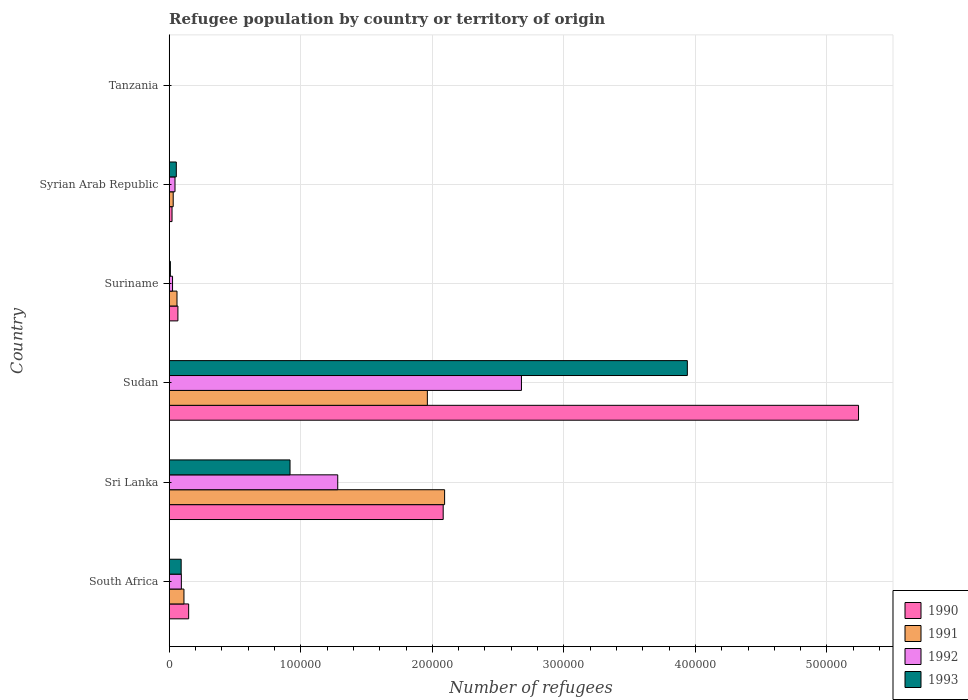How many different coloured bars are there?
Provide a succinct answer. 4. Are the number of bars per tick equal to the number of legend labels?
Ensure brevity in your answer.  Yes. What is the label of the 6th group of bars from the top?
Your answer should be compact. South Africa. In how many cases, is the number of bars for a given country not equal to the number of legend labels?
Your answer should be very brief. 0. What is the number of refugees in 1990 in Suriname?
Make the answer very short. 6620. Across all countries, what is the maximum number of refugees in 1991?
Your answer should be compact. 2.09e+05. Across all countries, what is the minimum number of refugees in 1992?
Give a very brief answer. 20. In which country was the number of refugees in 1990 maximum?
Keep it short and to the point. Sudan. In which country was the number of refugees in 1990 minimum?
Make the answer very short. Tanzania. What is the total number of refugees in 1992 in the graph?
Provide a short and direct response. 4.12e+05. What is the difference between the number of refugees in 1990 in Suriname and that in Syrian Arab Republic?
Ensure brevity in your answer.  4472. What is the difference between the number of refugees in 1992 in Syrian Arab Republic and the number of refugees in 1991 in Tanzania?
Make the answer very short. 4397. What is the average number of refugees in 1990 per country?
Provide a short and direct response. 1.26e+05. In how many countries, is the number of refugees in 1992 greater than 80000 ?
Keep it short and to the point. 2. What is the ratio of the number of refugees in 1993 in Sudan to that in Syrian Arab Republic?
Your answer should be compact. 72.89. Is the number of refugees in 1990 in South Africa less than that in Syrian Arab Republic?
Your answer should be very brief. No. Is the difference between the number of refugees in 1993 in Sri Lanka and Tanzania greater than the difference between the number of refugees in 1992 in Sri Lanka and Tanzania?
Give a very brief answer. No. What is the difference between the highest and the second highest number of refugees in 1992?
Make the answer very short. 1.40e+05. What is the difference between the highest and the lowest number of refugees in 1991?
Make the answer very short. 2.09e+05. Is the sum of the number of refugees in 1993 in Sudan and Tanzania greater than the maximum number of refugees in 1990 across all countries?
Provide a succinct answer. No. What does the 1st bar from the top in Tanzania represents?
Offer a very short reply. 1993. What does the 3rd bar from the bottom in Syrian Arab Republic represents?
Your answer should be very brief. 1992. Are all the bars in the graph horizontal?
Provide a succinct answer. Yes. Are the values on the major ticks of X-axis written in scientific E-notation?
Provide a short and direct response. No. Where does the legend appear in the graph?
Your response must be concise. Bottom right. How many legend labels are there?
Your answer should be very brief. 4. What is the title of the graph?
Make the answer very short. Refugee population by country or territory of origin. What is the label or title of the X-axis?
Your response must be concise. Number of refugees. What is the Number of refugees of 1990 in South Africa?
Give a very brief answer. 1.48e+04. What is the Number of refugees of 1991 in South Africa?
Provide a short and direct response. 1.12e+04. What is the Number of refugees in 1992 in South Africa?
Provide a succinct answer. 9241. What is the Number of refugees in 1993 in South Africa?
Offer a terse response. 9094. What is the Number of refugees in 1990 in Sri Lanka?
Your response must be concise. 2.08e+05. What is the Number of refugees in 1991 in Sri Lanka?
Offer a very short reply. 2.09e+05. What is the Number of refugees in 1992 in Sri Lanka?
Your response must be concise. 1.28e+05. What is the Number of refugees in 1993 in Sri Lanka?
Give a very brief answer. 9.18e+04. What is the Number of refugees in 1990 in Sudan?
Offer a terse response. 5.24e+05. What is the Number of refugees in 1991 in Sudan?
Your answer should be compact. 1.96e+05. What is the Number of refugees in 1992 in Sudan?
Your answer should be very brief. 2.68e+05. What is the Number of refugees in 1993 in Sudan?
Provide a succinct answer. 3.94e+05. What is the Number of refugees of 1990 in Suriname?
Offer a terse response. 6620. What is the Number of refugees of 1991 in Suriname?
Ensure brevity in your answer.  5921. What is the Number of refugees of 1992 in Suriname?
Ensure brevity in your answer.  2545. What is the Number of refugees in 1993 in Suriname?
Your response must be concise. 893. What is the Number of refugees of 1990 in Syrian Arab Republic?
Give a very brief answer. 2148. What is the Number of refugees of 1991 in Syrian Arab Republic?
Ensure brevity in your answer.  3037. What is the Number of refugees of 1992 in Syrian Arab Republic?
Make the answer very short. 4408. What is the Number of refugees of 1993 in Syrian Arab Republic?
Keep it short and to the point. 5404. What is the Number of refugees in 1992 in Tanzania?
Offer a terse response. 20. Across all countries, what is the maximum Number of refugees of 1990?
Provide a short and direct response. 5.24e+05. Across all countries, what is the maximum Number of refugees in 1991?
Your answer should be very brief. 2.09e+05. Across all countries, what is the maximum Number of refugees in 1992?
Offer a very short reply. 2.68e+05. Across all countries, what is the maximum Number of refugees in 1993?
Your answer should be very brief. 3.94e+05. Across all countries, what is the minimum Number of refugees of 1991?
Your response must be concise. 11. Across all countries, what is the minimum Number of refugees of 1992?
Provide a succinct answer. 20. Across all countries, what is the minimum Number of refugees of 1993?
Ensure brevity in your answer.  32. What is the total Number of refugees in 1990 in the graph?
Your answer should be very brief. 7.56e+05. What is the total Number of refugees in 1991 in the graph?
Ensure brevity in your answer.  4.26e+05. What is the total Number of refugees of 1992 in the graph?
Your response must be concise. 4.12e+05. What is the total Number of refugees in 1993 in the graph?
Your response must be concise. 5.01e+05. What is the difference between the Number of refugees of 1990 in South Africa and that in Sri Lanka?
Ensure brevity in your answer.  -1.93e+05. What is the difference between the Number of refugees in 1991 in South Africa and that in Sri Lanka?
Your answer should be compact. -1.98e+05. What is the difference between the Number of refugees of 1992 in South Africa and that in Sri Lanka?
Your response must be concise. -1.19e+05. What is the difference between the Number of refugees of 1993 in South Africa and that in Sri Lanka?
Provide a short and direct response. -8.28e+04. What is the difference between the Number of refugees in 1990 in South Africa and that in Sudan?
Your answer should be very brief. -5.09e+05. What is the difference between the Number of refugees in 1991 in South Africa and that in Sudan?
Provide a short and direct response. -1.85e+05. What is the difference between the Number of refugees in 1992 in South Africa and that in Sudan?
Ensure brevity in your answer.  -2.59e+05. What is the difference between the Number of refugees in 1993 in South Africa and that in Sudan?
Offer a very short reply. -3.85e+05. What is the difference between the Number of refugees in 1990 in South Africa and that in Suriname?
Your response must be concise. 8163. What is the difference between the Number of refugees of 1991 in South Africa and that in Suriname?
Provide a short and direct response. 5285. What is the difference between the Number of refugees in 1992 in South Africa and that in Suriname?
Offer a terse response. 6696. What is the difference between the Number of refugees of 1993 in South Africa and that in Suriname?
Provide a succinct answer. 8201. What is the difference between the Number of refugees of 1990 in South Africa and that in Syrian Arab Republic?
Provide a short and direct response. 1.26e+04. What is the difference between the Number of refugees of 1991 in South Africa and that in Syrian Arab Republic?
Make the answer very short. 8169. What is the difference between the Number of refugees in 1992 in South Africa and that in Syrian Arab Republic?
Your answer should be compact. 4833. What is the difference between the Number of refugees in 1993 in South Africa and that in Syrian Arab Republic?
Your answer should be very brief. 3690. What is the difference between the Number of refugees of 1990 in South Africa and that in Tanzania?
Your response must be concise. 1.48e+04. What is the difference between the Number of refugees in 1991 in South Africa and that in Tanzania?
Provide a short and direct response. 1.12e+04. What is the difference between the Number of refugees in 1992 in South Africa and that in Tanzania?
Ensure brevity in your answer.  9221. What is the difference between the Number of refugees of 1993 in South Africa and that in Tanzania?
Provide a succinct answer. 9062. What is the difference between the Number of refugees in 1990 in Sri Lanka and that in Sudan?
Keep it short and to the point. -3.16e+05. What is the difference between the Number of refugees of 1991 in Sri Lanka and that in Sudan?
Ensure brevity in your answer.  1.31e+04. What is the difference between the Number of refugees in 1992 in Sri Lanka and that in Sudan?
Ensure brevity in your answer.  -1.40e+05. What is the difference between the Number of refugees in 1993 in Sri Lanka and that in Sudan?
Your answer should be compact. -3.02e+05. What is the difference between the Number of refugees in 1990 in Sri Lanka and that in Suriname?
Your answer should be very brief. 2.02e+05. What is the difference between the Number of refugees in 1991 in Sri Lanka and that in Suriname?
Give a very brief answer. 2.03e+05. What is the difference between the Number of refugees of 1992 in Sri Lanka and that in Suriname?
Ensure brevity in your answer.  1.26e+05. What is the difference between the Number of refugees of 1993 in Sri Lanka and that in Suriname?
Ensure brevity in your answer.  9.10e+04. What is the difference between the Number of refugees of 1990 in Sri Lanka and that in Syrian Arab Republic?
Offer a terse response. 2.06e+05. What is the difference between the Number of refugees of 1991 in Sri Lanka and that in Syrian Arab Republic?
Offer a very short reply. 2.06e+05. What is the difference between the Number of refugees of 1992 in Sri Lanka and that in Syrian Arab Republic?
Ensure brevity in your answer.  1.24e+05. What is the difference between the Number of refugees of 1993 in Sri Lanka and that in Syrian Arab Republic?
Provide a succinct answer. 8.64e+04. What is the difference between the Number of refugees in 1990 in Sri Lanka and that in Tanzania?
Provide a short and direct response. 2.08e+05. What is the difference between the Number of refugees in 1991 in Sri Lanka and that in Tanzania?
Your response must be concise. 2.09e+05. What is the difference between the Number of refugees in 1992 in Sri Lanka and that in Tanzania?
Give a very brief answer. 1.28e+05. What is the difference between the Number of refugees in 1993 in Sri Lanka and that in Tanzania?
Ensure brevity in your answer.  9.18e+04. What is the difference between the Number of refugees of 1990 in Sudan and that in Suriname?
Give a very brief answer. 5.17e+05. What is the difference between the Number of refugees in 1991 in Sudan and that in Suriname?
Your response must be concise. 1.90e+05. What is the difference between the Number of refugees of 1992 in Sudan and that in Suriname?
Offer a terse response. 2.65e+05. What is the difference between the Number of refugees of 1993 in Sudan and that in Suriname?
Give a very brief answer. 3.93e+05. What is the difference between the Number of refugees of 1990 in Sudan and that in Syrian Arab Republic?
Ensure brevity in your answer.  5.22e+05. What is the difference between the Number of refugees of 1991 in Sudan and that in Syrian Arab Republic?
Ensure brevity in your answer.  1.93e+05. What is the difference between the Number of refugees of 1992 in Sudan and that in Syrian Arab Republic?
Make the answer very short. 2.63e+05. What is the difference between the Number of refugees in 1993 in Sudan and that in Syrian Arab Republic?
Your answer should be very brief. 3.88e+05. What is the difference between the Number of refugees of 1990 in Sudan and that in Tanzania?
Ensure brevity in your answer.  5.24e+05. What is the difference between the Number of refugees in 1991 in Sudan and that in Tanzania?
Make the answer very short. 1.96e+05. What is the difference between the Number of refugees of 1992 in Sudan and that in Tanzania?
Offer a terse response. 2.68e+05. What is the difference between the Number of refugees of 1993 in Sudan and that in Tanzania?
Offer a very short reply. 3.94e+05. What is the difference between the Number of refugees of 1990 in Suriname and that in Syrian Arab Republic?
Offer a terse response. 4472. What is the difference between the Number of refugees in 1991 in Suriname and that in Syrian Arab Republic?
Ensure brevity in your answer.  2884. What is the difference between the Number of refugees in 1992 in Suriname and that in Syrian Arab Republic?
Provide a succinct answer. -1863. What is the difference between the Number of refugees in 1993 in Suriname and that in Syrian Arab Republic?
Ensure brevity in your answer.  -4511. What is the difference between the Number of refugees of 1990 in Suriname and that in Tanzania?
Your response must be concise. 6612. What is the difference between the Number of refugees of 1991 in Suriname and that in Tanzania?
Your answer should be compact. 5910. What is the difference between the Number of refugees in 1992 in Suriname and that in Tanzania?
Your response must be concise. 2525. What is the difference between the Number of refugees in 1993 in Suriname and that in Tanzania?
Make the answer very short. 861. What is the difference between the Number of refugees in 1990 in Syrian Arab Republic and that in Tanzania?
Give a very brief answer. 2140. What is the difference between the Number of refugees in 1991 in Syrian Arab Republic and that in Tanzania?
Your answer should be compact. 3026. What is the difference between the Number of refugees in 1992 in Syrian Arab Republic and that in Tanzania?
Ensure brevity in your answer.  4388. What is the difference between the Number of refugees of 1993 in Syrian Arab Republic and that in Tanzania?
Offer a very short reply. 5372. What is the difference between the Number of refugees of 1990 in South Africa and the Number of refugees of 1991 in Sri Lanka?
Offer a terse response. -1.95e+05. What is the difference between the Number of refugees in 1990 in South Africa and the Number of refugees in 1992 in Sri Lanka?
Your response must be concise. -1.13e+05. What is the difference between the Number of refugees of 1990 in South Africa and the Number of refugees of 1993 in Sri Lanka?
Keep it short and to the point. -7.71e+04. What is the difference between the Number of refugees in 1991 in South Africa and the Number of refugees in 1992 in Sri Lanka?
Offer a terse response. -1.17e+05. What is the difference between the Number of refugees of 1991 in South Africa and the Number of refugees of 1993 in Sri Lanka?
Provide a succinct answer. -8.06e+04. What is the difference between the Number of refugees of 1992 in South Africa and the Number of refugees of 1993 in Sri Lanka?
Your response must be concise. -8.26e+04. What is the difference between the Number of refugees in 1990 in South Africa and the Number of refugees in 1991 in Sudan?
Keep it short and to the point. -1.81e+05. What is the difference between the Number of refugees in 1990 in South Africa and the Number of refugees in 1992 in Sudan?
Your answer should be compact. -2.53e+05. What is the difference between the Number of refugees in 1990 in South Africa and the Number of refugees in 1993 in Sudan?
Give a very brief answer. -3.79e+05. What is the difference between the Number of refugees of 1991 in South Africa and the Number of refugees of 1992 in Sudan?
Provide a short and direct response. -2.57e+05. What is the difference between the Number of refugees in 1991 in South Africa and the Number of refugees in 1993 in Sudan?
Provide a succinct answer. -3.83e+05. What is the difference between the Number of refugees in 1992 in South Africa and the Number of refugees in 1993 in Sudan?
Give a very brief answer. -3.85e+05. What is the difference between the Number of refugees in 1990 in South Africa and the Number of refugees in 1991 in Suriname?
Give a very brief answer. 8862. What is the difference between the Number of refugees in 1990 in South Africa and the Number of refugees in 1992 in Suriname?
Your answer should be very brief. 1.22e+04. What is the difference between the Number of refugees in 1990 in South Africa and the Number of refugees in 1993 in Suriname?
Offer a very short reply. 1.39e+04. What is the difference between the Number of refugees in 1991 in South Africa and the Number of refugees in 1992 in Suriname?
Your answer should be compact. 8661. What is the difference between the Number of refugees of 1991 in South Africa and the Number of refugees of 1993 in Suriname?
Your response must be concise. 1.03e+04. What is the difference between the Number of refugees in 1992 in South Africa and the Number of refugees in 1993 in Suriname?
Your response must be concise. 8348. What is the difference between the Number of refugees of 1990 in South Africa and the Number of refugees of 1991 in Syrian Arab Republic?
Your answer should be very brief. 1.17e+04. What is the difference between the Number of refugees in 1990 in South Africa and the Number of refugees in 1992 in Syrian Arab Republic?
Offer a terse response. 1.04e+04. What is the difference between the Number of refugees of 1990 in South Africa and the Number of refugees of 1993 in Syrian Arab Republic?
Your response must be concise. 9379. What is the difference between the Number of refugees of 1991 in South Africa and the Number of refugees of 1992 in Syrian Arab Republic?
Offer a terse response. 6798. What is the difference between the Number of refugees in 1991 in South Africa and the Number of refugees in 1993 in Syrian Arab Republic?
Keep it short and to the point. 5802. What is the difference between the Number of refugees in 1992 in South Africa and the Number of refugees in 1993 in Syrian Arab Republic?
Provide a succinct answer. 3837. What is the difference between the Number of refugees in 1990 in South Africa and the Number of refugees in 1991 in Tanzania?
Give a very brief answer. 1.48e+04. What is the difference between the Number of refugees of 1990 in South Africa and the Number of refugees of 1992 in Tanzania?
Provide a short and direct response. 1.48e+04. What is the difference between the Number of refugees of 1990 in South Africa and the Number of refugees of 1993 in Tanzania?
Keep it short and to the point. 1.48e+04. What is the difference between the Number of refugees in 1991 in South Africa and the Number of refugees in 1992 in Tanzania?
Your answer should be very brief. 1.12e+04. What is the difference between the Number of refugees in 1991 in South Africa and the Number of refugees in 1993 in Tanzania?
Make the answer very short. 1.12e+04. What is the difference between the Number of refugees of 1992 in South Africa and the Number of refugees of 1993 in Tanzania?
Provide a short and direct response. 9209. What is the difference between the Number of refugees of 1990 in Sri Lanka and the Number of refugees of 1991 in Sudan?
Keep it short and to the point. 1.20e+04. What is the difference between the Number of refugees of 1990 in Sri Lanka and the Number of refugees of 1992 in Sudan?
Provide a succinct answer. -5.95e+04. What is the difference between the Number of refugees of 1990 in Sri Lanka and the Number of refugees of 1993 in Sudan?
Ensure brevity in your answer.  -1.86e+05. What is the difference between the Number of refugees in 1991 in Sri Lanka and the Number of refugees in 1992 in Sudan?
Provide a succinct answer. -5.84e+04. What is the difference between the Number of refugees in 1991 in Sri Lanka and the Number of refugees in 1993 in Sudan?
Provide a short and direct response. -1.85e+05. What is the difference between the Number of refugees in 1992 in Sri Lanka and the Number of refugees in 1993 in Sudan?
Offer a very short reply. -2.66e+05. What is the difference between the Number of refugees of 1990 in Sri Lanka and the Number of refugees of 1991 in Suriname?
Make the answer very short. 2.02e+05. What is the difference between the Number of refugees in 1990 in Sri Lanka and the Number of refugees in 1992 in Suriname?
Offer a terse response. 2.06e+05. What is the difference between the Number of refugees in 1990 in Sri Lanka and the Number of refugees in 1993 in Suriname?
Keep it short and to the point. 2.07e+05. What is the difference between the Number of refugees in 1991 in Sri Lanka and the Number of refugees in 1992 in Suriname?
Your answer should be very brief. 2.07e+05. What is the difference between the Number of refugees of 1991 in Sri Lanka and the Number of refugees of 1993 in Suriname?
Provide a short and direct response. 2.08e+05. What is the difference between the Number of refugees in 1992 in Sri Lanka and the Number of refugees in 1993 in Suriname?
Your answer should be compact. 1.27e+05. What is the difference between the Number of refugees in 1990 in Sri Lanka and the Number of refugees in 1991 in Syrian Arab Republic?
Give a very brief answer. 2.05e+05. What is the difference between the Number of refugees in 1990 in Sri Lanka and the Number of refugees in 1992 in Syrian Arab Republic?
Keep it short and to the point. 2.04e+05. What is the difference between the Number of refugees in 1990 in Sri Lanka and the Number of refugees in 1993 in Syrian Arab Republic?
Your response must be concise. 2.03e+05. What is the difference between the Number of refugees of 1991 in Sri Lanka and the Number of refugees of 1992 in Syrian Arab Republic?
Offer a very short reply. 2.05e+05. What is the difference between the Number of refugees of 1991 in Sri Lanka and the Number of refugees of 1993 in Syrian Arab Republic?
Keep it short and to the point. 2.04e+05. What is the difference between the Number of refugees in 1992 in Sri Lanka and the Number of refugees in 1993 in Syrian Arab Republic?
Provide a succinct answer. 1.23e+05. What is the difference between the Number of refugees in 1990 in Sri Lanka and the Number of refugees in 1991 in Tanzania?
Keep it short and to the point. 2.08e+05. What is the difference between the Number of refugees of 1990 in Sri Lanka and the Number of refugees of 1992 in Tanzania?
Offer a terse response. 2.08e+05. What is the difference between the Number of refugees of 1990 in Sri Lanka and the Number of refugees of 1993 in Tanzania?
Keep it short and to the point. 2.08e+05. What is the difference between the Number of refugees of 1991 in Sri Lanka and the Number of refugees of 1992 in Tanzania?
Make the answer very short. 2.09e+05. What is the difference between the Number of refugees of 1991 in Sri Lanka and the Number of refugees of 1993 in Tanzania?
Your answer should be compact. 2.09e+05. What is the difference between the Number of refugees of 1992 in Sri Lanka and the Number of refugees of 1993 in Tanzania?
Make the answer very short. 1.28e+05. What is the difference between the Number of refugees in 1990 in Sudan and the Number of refugees in 1991 in Suriname?
Keep it short and to the point. 5.18e+05. What is the difference between the Number of refugees of 1990 in Sudan and the Number of refugees of 1992 in Suriname?
Give a very brief answer. 5.21e+05. What is the difference between the Number of refugees of 1990 in Sudan and the Number of refugees of 1993 in Suriname?
Make the answer very short. 5.23e+05. What is the difference between the Number of refugees of 1991 in Sudan and the Number of refugees of 1992 in Suriname?
Give a very brief answer. 1.94e+05. What is the difference between the Number of refugees of 1991 in Sudan and the Number of refugees of 1993 in Suriname?
Offer a terse response. 1.95e+05. What is the difference between the Number of refugees of 1992 in Sudan and the Number of refugees of 1993 in Suriname?
Provide a succinct answer. 2.67e+05. What is the difference between the Number of refugees of 1990 in Sudan and the Number of refugees of 1991 in Syrian Arab Republic?
Provide a succinct answer. 5.21e+05. What is the difference between the Number of refugees of 1990 in Sudan and the Number of refugees of 1992 in Syrian Arab Republic?
Give a very brief answer. 5.20e+05. What is the difference between the Number of refugees in 1990 in Sudan and the Number of refugees in 1993 in Syrian Arab Republic?
Your response must be concise. 5.19e+05. What is the difference between the Number of refugees in 1991 in Sudan and the Number of refugees in 1992 in Syrian Arab Republic?
Offer a very short reply. 1.92e+05. What is the difference between the Number of refugees of 1991 in Sudan and the Number of refugees of 1993 in Syrian Arab Republic?
Your response must be concise. 1.91e+05. What is the difference between the Number of refugees in 1992 in Sudan and the Number of refugees in 1993 in Syrian Arab Republic?
Give a very brief answer. 2.62e+05. What is the difference between the Number of refugees in 1990 in Sudan and the Number of refugees in 1991 in Tanzania?
Offer a terse response. 5.24e+05. What is the difference between the Number of refugees of 1990 in Sudan and the Number of refugees of 1992 in Tanzania?
Offer a very short reply. 5.24e+05. What is the difference between the Number of refugees of 1990 in Sudan and the Number of refugees of 1993 in Tanzania?
Offer a terse response. 5.24e+05. What is the difference between the Number of refugees in 1991 in Sudan and the Number of refugees in 1992 in Tanzania?
Provide a short and direct response. 1.96e+05. What is the difference between the Number of refugees of 1991 in Sudan and the Number of refugees of 1993 in Tanzania?
Provide a short and direct response. 1.96e+05. What is the difference between the Number of refugees of 1992 in Sudan and the Number of refugees of 1993 in Tanzania?
Ensure brevity in your answer.  2.68e+05. What is the difference between the Number of refugees of 1990 in Suriname and the Number of refugees of 1991 in Syrian Arab Republic?
Keep it short and to the point. 3583. What is the difference between the Number of refugees in 1990 in Suriname and the Number of refugees in 1992 in Syrian Arab Republic?
Make the answer very short. 2212. What is the difference between the Number of refugees in 1990 in Suriname and the Number of refugees in 1993 in Syrian Arab Republic?
Your answer should be compact. 1216. What is the difference between the Number of refugees of 1991 in Suriname and the Number of refugees of 1992 in Syrian Arab Republic?
Offer a very short reply. 1513. What is the difference between the Number of refugees of 1991 in Suriname and the Number of refugees of 1993 in Syrian Arab Republic?
Your response must be concise. 517. What is the difference between the Number of refugees of 1992 in Suriname and the Number of refugees of 1993 in Syrian Arab Republic?
Your answer should be compact. -2859. What is the difference between the Number of refugees in 1990 in Suriname and the Number of refugees in 1991 in Tanzania?
Ensure brevity in your answer.  6609. What is the difference between the Number of refugees in 1990 in Suriname and the Number of refugees in 1992 in Tanzania?
Keep it short and to the point. 6600. What is the difference between the Number of refugees in 1990 in Suriname and the Number of refugees in 1993 in Tanzania?
Offer a very short reply. 6588. What is the difference between the Number of refugees of 1991 in Suriname and the Number of refugees of 1992 in Tanzania?
Offer a very short reply. 5901. What is the difference between the Number of refugees of 1991 in Suriname and the Number of refugees of 1993 in Tanzania?
Offer a very short reply. 5889. What is the difference between the Number of refugees of 1992 in Suriname and the Number of refugees of 1993 in Tanzania?
Your response must be concise. 2513. What is the difference between the Number of refugees of 1990 in Syrian Arab Republic and the Number of refugees of 1991 in Tanzania?
Offer a very short reply. 2137. What is the difference between the Number of refugees of 1990 in Syrian Arab Republic and the Number of refugees of 1992 in Tanzania?
Give a very brief answer. 2128. What is the difference between the Number of refugees in 1990 in Syrian Arab Republic and the Number of refugees in 1993 in Tanzania?
Give a very brief answer. 2116. What is the difference between the Number of refugees in 1991 in Syrian Arab Republic and the Number of refugees in 1992 in Tanzania?
Give a very brief answer. 3017. What is the difference between the Number of refugees of 1991 in Syrian Arab Republic and the Number of refugees of 1993 in Tanzania?
Make the answer very short. 3005. What is the difference between the Number of refugees in 1992 in Syrian Arab Republic and the Number of refugees in 1993 in Tanzania?
Make the answer very short. 4376. What is the average Number of refugees in 1990 per country?
Offer a very short reply. 1.26e+05. What is the average Number of refugees of 1991 per country?
Your answer should be compact. 7.10e+04. What is the average Number of refugees of 1992 per country?
Ensure brevity in your answer.  6.87e+04. What is the average Number of refugees in 1993 per country?
Your answer should be compact. 8.35e+04. What is the difference between the Number of refugees of 1990 and Number of refugees of 1991 in South Africa?
Your answer should be very brief. 3577. What is the difference between the Number of refugees of 1990 and Number of refugees of 1992 in South Africa?
Your response must be concise. 5542. What is the difference between the Number of refugees in 1990 and Number of refugees in 1993 in South Africa?
Keep it short and to the point. 5689. What is the difference between the Number of refugees of 1991 and Number of refugees of 1992 in South Africa?
Your answer should be very brief. 1965. What is the difference between the Number of refugees in 1991 and Number of refugees in 1993 in South Africa?
Offer a very short reply. 2112. What is the difference between the Number of refugees in 1992 and Number of refugees in 1993 in South Africa?
Make the answer very short. 147. What is the difference between the Number of refugees of 1990 and Number of refugees of 1991 in Sri Lanka?
Make the answer very short. -1078. What is the difference between the Number of refugees in 1990 and Number of refugees in 1992 in Sri Lanka?
Your response must be concise. 8.02e+04. What is the difference between the Number of refugees in 1990 and Number of refugees in 1993 in Sri Lanka?
Give a very brief answer. 1.16e+05. What is the difference between the Number of refugees in 1991 and Number of refugees in 1992 in Sri Lanka?
Your response must be concise. 8.12e+04. What is the difference between the Number of refugees of 1991 and Number of refugees of 1993 in Sri Lanka?
Your answer should be compact. 1.18e+05. What is the difference between the Number of refugees in 1992 and Number of refugees in 1993 in Sri Lanka?
Make the answer very short. 3.63e+04. What is the difference between the Number of refugees of 1990 and Number of refugees of 1991 in Sudan?
Offer a very short reply. 3.28e+05. What is the difference between the Number of refugees of 1990 and Number of refugees of 1992 in Sudan?
Provide a succinct answer. 2.56e+05. What is the difference between the Number of refugees of 1990 and Number of refugees of 1993 in Sudan?
Provide a short and direct response. 1.30e+05. What is the difference between the Number of refugees of 1991 and Number of refugees of 1992 in Sudan?
Provide a short and direct response. -7.15e+04. What is the difference between the Number of refugees in 1991 and Number of refugees in 1993 in Sudan?
Your answer should be very brief. -1.98e+05. What is the difference between the Number of refugees of 1992 and Number of refugees of 1993 in Sudan?
Your response must be concise. -1.26e+05. What is the difference between the Number of refugees of 1990 and Number of refugees of 1991 in Suriname?
Your answer should be very brief. 699. What is the difference between the Number of refugees of 1990 and Number of refugees of 1992 in Suriname?
Ensure brevity in your answer.  4075. What is the difference between the Number of refugees of 1990 and Number of refugees of 1993 in Suriname?
Make the answer very short. 5727. What is the difference between the Number of refugees in 1991 and Number of refugees in 1992 in Suriname?
Your answer should be compact. 3376. What is the difference between the Number of refugees in 1991 and Number of refugees in 1993 in Suriname?
Give a very brief answer. 5028. What is the difference between the Number of refugees in 1992 and Number of refugees in 1993 in Suriname?
Ensure brevity in your answer.  1652. What is the difference between the Number of refugees in 1990 and Number of refugees in 1991 in Syrian Arab Republic?
Your answer should be very brief. -889. What is the difference between the Number of refugees of 1990 and Number of refugees of 1992 in Syrian Arab Republic?
Your answer should be compact. -2260. What is the difference between the Number of refugees in 1990 and Number of refugees in 1993 in Syrian Arab Republic?
Ensure brevity in your answer.  -3256. What is the difference between the Number of refugees of 1991 and Number of refugees of 1992 in Syrian Arab Republic?
Provide a succinct answer. -1371. What is the difference between the Number of refugees in 1991 and Number of refugees in 1993 in Syrian Arab Republic?
Your answer should be very brief. -2367. What is the difference between the Number of refugees in 1992 and Number of refugees in 1993 in Syrian Arab Republic?
Your answer should be compact. -996. What is the difference between the Number of refugees of 1990 and Number of refugees of 1992 in Tanzania?
Provide a succinct answer. -12. What is the difference between the Number of refugees of 1990 and Number of refugees of 1993 in Tanzania?
Keep it short and to the point. -24. What is the difference between the Number of refugees of 1992 and Number of refugees of 1993 in Tanzania?
Provide a succinct answer. -12. What is the ratio of the Number of refugees in 1990 in South Africa to that in Sri Lanka?
Make the answer very short. 0.07. What is the ratio of the Number of refugees of 1991 in South Africa to that in Sri Lanka?
Your answer should be very brief. 0.05. What is the ratio of the Number of refugees in 1992 in South Africa to that in Sri Lanka?
Your answer should be very brief. 0.07. What is the ratio of the Number of refugees of 1993 in South Africa to that in Sri Lanka?
Provide a succinct answer. 0.1. What is the ratio of the Number of refugees in 1990 in South Africa to that in Sudan?
Provide a succinct answer. 0.03. What is the ratio of the Number of refugees of 1991 in South Africa to that in Sudan?
Make the answer very short. 0.06. What is the ratio of the Number of refugees of 1992 in South Africa to that in Sudan?
Your response must be concise. 0.03. What is the ratio of the Number of refugees of 1993 in South Africa to that in Sudan?
Keep it short and to the point. 0.02. What is the ratio of the Number of refugees in 1990 in South Africa to that in Suriname?
Provide a short and direct response. 2.23. What is the ratio of the Number of refugees in 1991 in South Africa to that in Suriname?
Ensure brevity in your answer.  1.89. What is the ratio of the Number of refugees of 1992 in South Africa to that in Suriname?
Provide a succinct answer. 3.63. What is the ratio of the Number of refugees in 1993 in South Africa to that in Suriname?
Make the answer very short. 10.18. What is the ratio of the Number of refugees of 1990 in South Africa to that in Syrian Arab Republic?
Your answer should be very brief. 6.88. What is the ratio of the Number of refugees of 1991 in South Africa to that in Syrian Arab Republic?
Your answer should be very brief. 3.69. What is the ratio of the Number of refugees in 1992 in South Africa to that in Syrian Arab Republic?
Your response must be concise. 2.1. What is the ratio of the Number of refugees in 1993 in South Africa to that in Syrian Arab Republic?
Your response must be concise. 1.68. What is the ratio of the Number of refugees of 1990 in South Africa to that in Tanzania?
Ensure brevity in your answer.  1847.88. What is the ratio of the Number of refugees of 1991 in South Africa to that in Tanzania?
Your response must be concise. 1018.73. What is the ratio of the Number of refugees of 1992 in South Africa to that in Tanzania?
Provide a succinct answer. 462.05. What is the ratio of the Number of refugees of 1993 in South Africa to that in Tanzania?
Your answer should be very brief. 284.19. What is the ratio of the Number of refugees of 1990 in Sri Lanka to that in Sudan?
Your answer should be very brief. 0.4. What is the ratio of the Number of refugees of 1991 in Sri Lanka to that in Sudan?
Offer a very short reply. 1.07. What is the ratio of the Number of refugees in 1992 in Sri Lanka to that in Sudan?
Your response must be concise. 0.48. What is the ratio of the Number of refugees in 1993 in Sri Lanka to that in Sudan?
Your response must be concise. 0.23. What is the ratio of the Number of refugees of 1990 in Sri Lanka to that in Suriname?
Keep it short and to the point. 31.46. What is the ratio of the Number of refugees of 1991 in Sri Lanka to that in Suriname?
Give a very brief answer. 35.36. What is the ratio of the Number of refugees in 1992 in Sri Lanka to that in Suriname?
Offer a very short reply. 50.34. What is the ratio of the Number of refugees in 1993 in Sri Lanka to that in Suriname?
Your response must be concise. 102.85. What is the ratio of the Number of refugees of 1990 in Sri Lanka to that in Syrian Arab Republic?
Offer a very short reply. 96.96. What is the ratio of the Number of refugees of 1991 in Sri Lanka to that in Syrian Arab Republic?
Offer a very short reply. 68.93. What is the ratio of the Number of refugees in 1992 in Sri Lanka to that in Syrian Arab Republic?
Make the answer very short. 29.06. What is the ratio of the Number of refugees in 1993 in Sri Lanka to that in Syrian Arab Republic?
Make the answer very short. 17. What is the ratio of the Number of refugees of 1990 in Sri Lanka to that in Tanzania?
Provide a succinct answer. 2.60e+04. What is the ratio of the Number of refugees in 1991 in Sri Lanka to that in Tanzania?
Make the answer very short. 1.90e+04. What is the ratio of the Number of refugees of 1992 in Sri Lanka to that in Tanzania?
Your answer should be very brief. 6405.75. What is the ratio of the Number of refugees in 1993 in Sri Lanka to that in Tanzania?
Keep it short and to the point. 2870.16. What is the ratio of the Number of refugees of 1990 in Sudan to that in Suriname?
Make the answer very short. 79.15. What is the ratio of the Number of refugees in 1991 in Sudan to that in Suriname?
Provide a succinct answer. 33.14. What is the ratio of the Number of refugees of 1992 in Sudan to that in Suriname?
Keep it short and to the point. 105.21. What is the ratio of the Number of refugees of 1993 in Sudan to that in Suriname?
Your response must be concise. 441.06. What is the ratio of the Number of refugees in 1990 in Sudan to that in Syrian Arab Republic?
Offer a terse response. 243.95. What is the ratio of the Number of refugees of 1991 in Sudan to that in Syrian Arab Republic?
Your answer should be very brief. 64.62. What is the ratio of the Number of refugees in 1992 in Sudan to that in Syrian Arab Republic?
Offer a very short reply. 60.75. What is the ratio of the Number of refugees of 1993 in Sudan to that in Syrian Arab Republic?
Ensure brevity in your answer.  72.89. What is the ratio of the Number of refugees in 1990 in Sudan to that in Tanzania?
Provide a short and direct response. 6.55e+04. What is the ratio of the Number of refugees of 1991 in Sudan to that in Tanzania?
Your answer should be compact. 1.78e+04. What is the ratio of the Number of refugees in 1992 in Sudan to that in Tanzania?
Provide a succinct answer. 1.34e+04. What is the ratio of the Number of refugees in 1993 in Sudan to that in Tanzania?
Your answer should be compact. 1.23e+04. What is the ratio of the Number of refugees in 1990 in Suriname to that in Syrian Arab Republic?
Provide a short and direct response. 3.08. What is the ratio of the Number of refugees in 1991 in Suriname to that in Syrian Arab Republic?
Ensure brevity in your answer.  1.95. What is the ratio of the Number of refugees in 1992 in Suriname to that in Syrian Arab Republic?
Keep it short and to the point. 0.58. What is the ratio of the Number of refugees in 1993 in Suriname to that in Syrian Arab Republic?
Your response must be concise. 0.17. What is the ratio of the Number of refugees of 1990 in Suriname to that in Tanzania?
Your answer should be very brief. 827.5. What is the ratio of the Number of refugees of 1991 in Suriname to that in Tanzania?
Your answer should be very brief. 538.27. What is the ratio of the Number of refugees in 1992 in Suriname to that in Tanzania?
Your answer should be very brief. 127.25. What is the ratio of the Number of refugees in 1993 in Suriname to that in Tanzania?
Your answer should be compact. 27.91. What is the ratio of the Number of refugees in 1990 in Syrian Arab Republic to that in Tanzania?
Offer a terse response. 268.5. What is the ratio of the Number of refugees in 1991 in Syrian Arab Republic to that in Tanzania?
Your response must be concise. 276.09. What is the ratio of the Number of refugees of 1992 in Syrian Arab Republic to that in Tanzania?
Make the answer very short. 220.4. What is the ratio of the Number of refugees of 1993 in Syrian Arab Republic to that in Tanzania?
Your answer should be compact. 168.88. What is the difference between the highest and the second highest Number of refugees in 1990?
Offer a very short reply. 3.16e+05. What is the difference between the highest and the second highest Number of refugees of 1991?
Ensure brevity in your answer.  1.31e+04. What is the difference between the highest and the second highest Number of refugees of 1992?
Provide a succinct answer. 1.40e+05. What is the difference between the highest and the second highest Number of refugees of 1993?
Offer a terse response. 3.02e+05. What is the difference between the highest and the lowest Number of refugees in 1990?
Your response must be concise. 5.24e+05. What is the difference between the highest and the lowest Number of refugees of 1991?
Keep it short and to the point. 2.09e+05. What is the difference between the highest and the lowest Number of refugees in 1992?
Make the answer very short. 2.68e+05. What is the difference between the highest and the lowest Number of refugees in 1993?
Make the answer very short. 3.94e+05. 